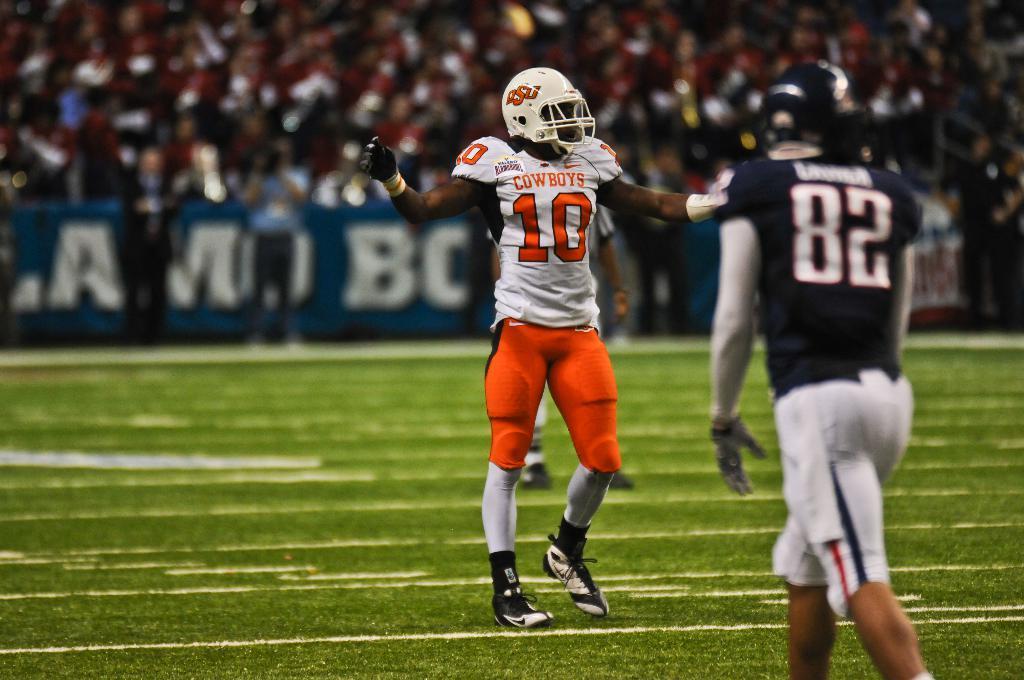Describe this image in one or two sentences. In this image I can see few people are wearing different color dresses. Back I can see the boards and blurred background. 